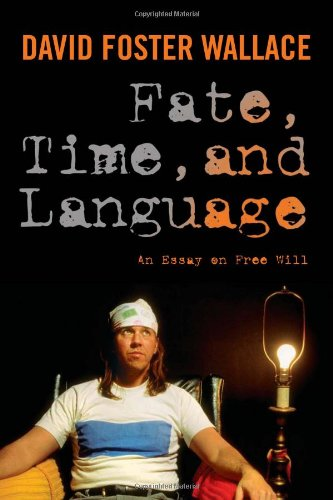Can you describe the appearance and setting depicted on the cover of this book? The cover features a photograph of David Foster Wallace sitting in a simple setting with what appears to be a domestic lamp beside him. His casual dress and contemplative expression, combined with the vintage aesthetics, evoke a personal and intellectual atmosphere. 